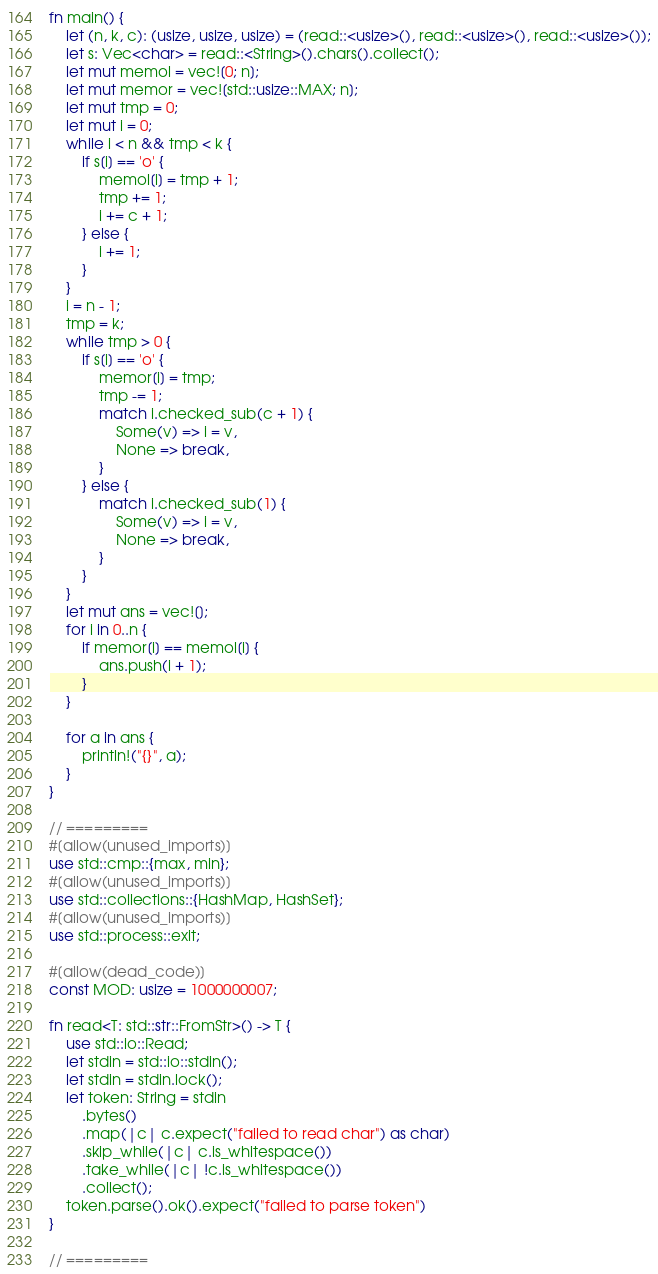<code> <loc_0><loc_0><loc_500><loc_500><_Rust_>fn main() {
    let (n, k, c): (usize, usize, usize) = (read::<usize>(), read::<usize>(), read::<usize>());
    let s: Vec<char> = read::<String>().chars().collect();
    let mut memol = vec![0; n];
    let mut memor = vec![std::usize::MAX; n];
    let mut tmp = 0;
    let mut i = 0;
    while i < n && tmp < k {
        if s[i] == 'o' {
            memol[i] = tmp + 1;
            tmp += 1;
            i += c + 1;
        } else {
            i += 1;
        }
    }
    i = n - 1;
    tmp = k;
    while tmp > 0 {
        if s[i] == 'o' {
            memor[i] = tmp;
            tmp -= 1;
            match i.checked_sub(c + 1) {
                Some(v) => i = v,
                None => break,
            }
        } else {
            match i.checked_sub(1) {
                Some(v) => i = v,
                None => break,
            }
        }
    }
    let mut ans = vec![];
    for i in 0..n {
        if memor[i] == memol[i] {
            ans.push(i + 1);
        }
    }

    for a in ans {
        println!("{}", a);
    }
}

// =========
#[allow(unused_imports)]
use std::cmp::{max, min};
#[allow(unused_imports)]
use std::collections::{HashMap, HashSet};
#[allow(unused_imports)]
use std::process::exit;

#[allow(dead_code)]
const MOD: usize = 1000000007;

fn read<T: std::str::FromStr>() -> T {
    use std::io::Read;
    let stdin = std::io::stdin();
    let stdin = stdin.lock();
    let token: String = stdin
        .bytes()
        .map(|c| c.expect("failed to read char") as char)
        .skip_while(|c| c.is_whitespace())
        .take_while(|c| !c.is_whitespace())
        .collect();
    token.parse().ok().expect("failed to parse token")
}

// =========
</code> 